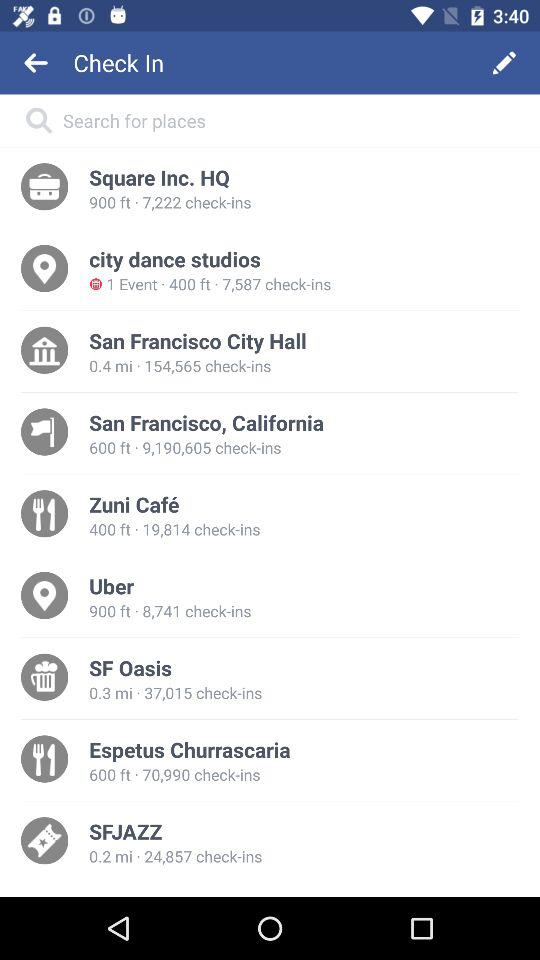Which place is having the higher number of check-in?
When the provided information is insufficient, respond with <no answer>. <no answer> 